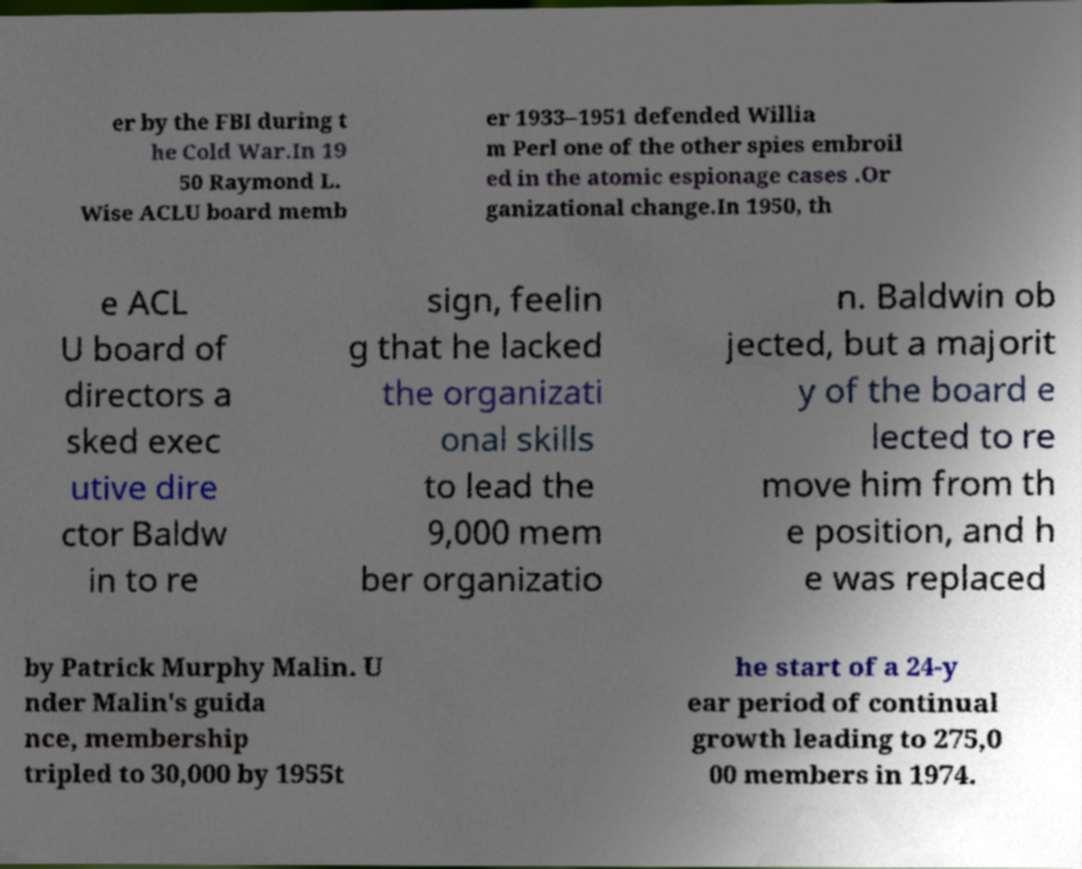Could you extract and type out the text from this image? er by the FBI during t he Cold War.In 19 50 Raymond L. Wise ACLU board memb er 1933–1951 defended Willia m Perl one of the other spies embroil ed in the atomic espionage cases .Or ganizational change.In 1950, th e ACL U board of directors a sked exec utive dire ctor Baldw in to re sign, feelin g that he lacked the organizati onal skills to lead the 9,000 mem ber organizatio n. Baldwin ob jected, but a majorit y of the board e lected to re move him from th e position, and h e was replaced by Patrick Murphy Malin. U nder Malin's guida nce, membership tripled to 30,000 by 1955t he start of a 24-y ear period of continual growth leading to 275,0 00 members in 1974. 